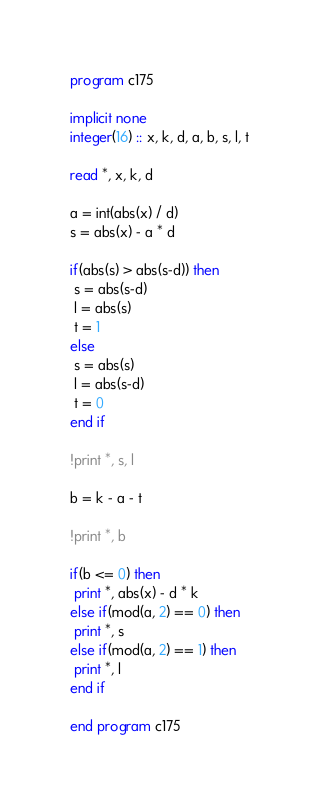<code> <loc_0><loc_0><loc_500><loc_500><_FORTRAN_>program c175

implicit none
integer(16) :: x, k, d, a, b, s, l, t

read *, x, k, d

a = int(abs(x) / d)
s = abs(x) - a * d

if(abs(s) > abs(s-d)) then
 s = abs(s-d)
 l = abs(s)
 t = 1
else
 s = abs(s)
 l = abs(s-d)
 t = 0
end if

!print *, s, l

b = k - a - t

!print *, b

if(b <= 0) then
 print *, abs(x) - d * k
else if(mod(a, 2) == 0) then
 print *, s
else if(mod(a, 2) == 1) then
 print *, l
end if

end program c175</code> 